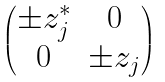<formula> <loc_0><loc_0><loc_500><loc_500>\begin{pmatrix} \pm z ^ { * } _ { j } & 0 \\ 0 & \pm z _ { j } \end{pmatrix}</formula> 